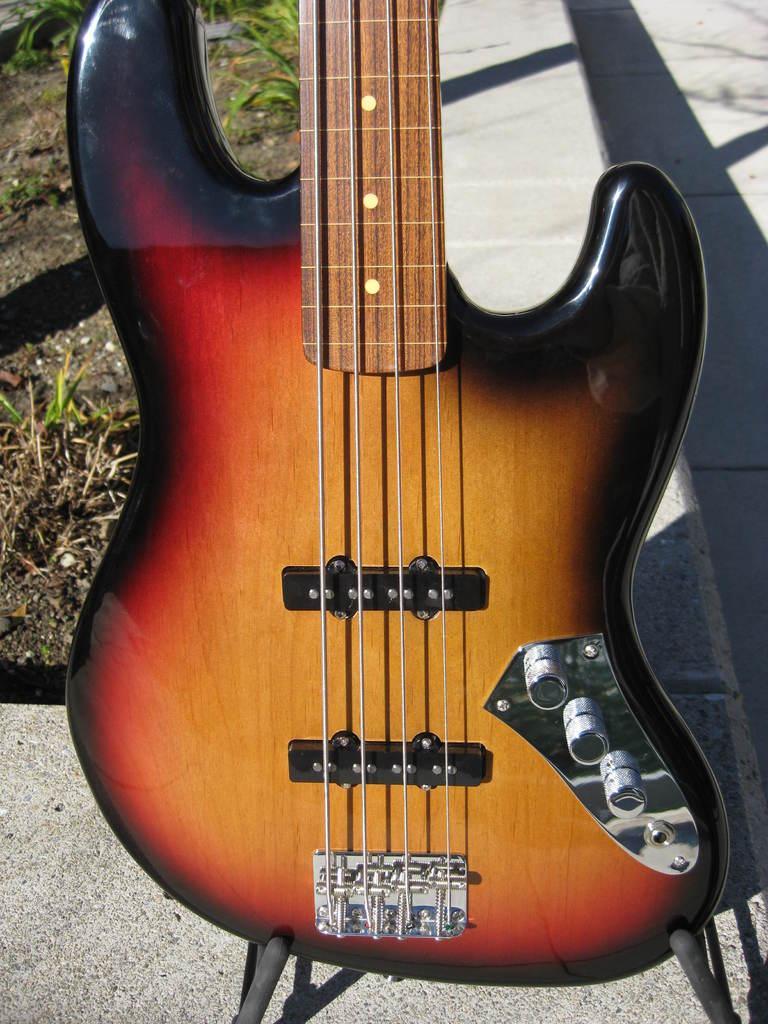Describe this image in one or two sentences. The picture is of a guitar which is of brown color it has total four strings in the background there is a shadow of the guitar, to the left there is soil and grass. 